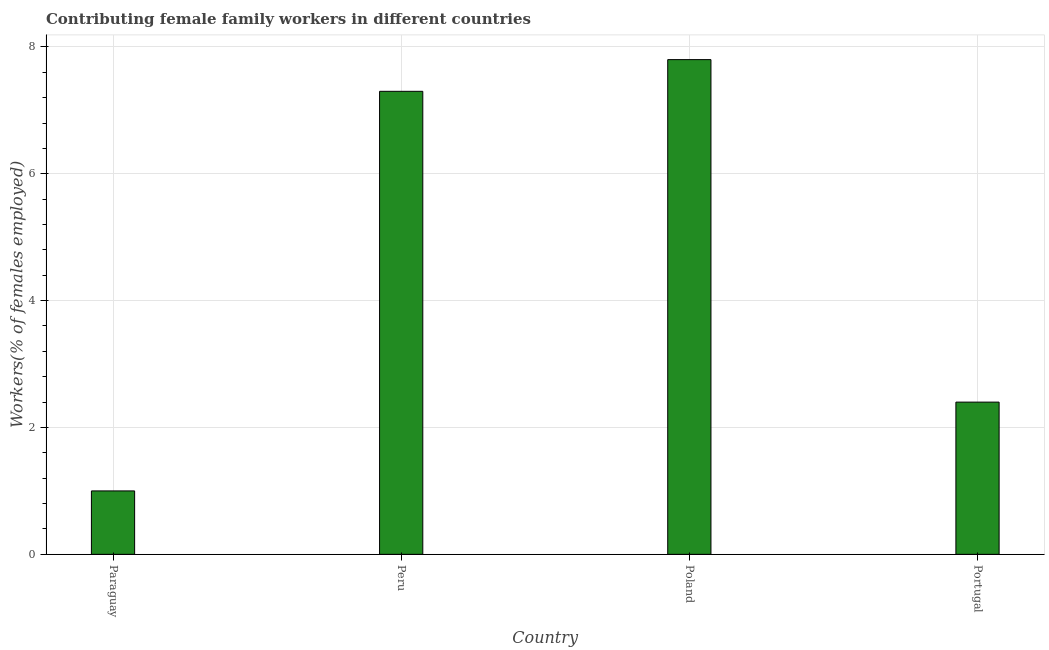Does the graph contain any zero values?
Ensure brevity in your answer.  No. Does the graph contain grids?
Give a very brief answer. Yes. What is the title of the graph?
Offer a very short reply. Contributing female family workers in different countries. What is the label or title of the X-axis?
Your answer should be very brief. Country. What is the label or title of the Y-axis?
Give a very brief answer. Workers(% of females employed). What is the contributing female family workers in Peru?
Your answer should be very brief. 7.3. Across all countries, what is the maximum contributing female family workers?
Make the answer very short. 7.8. In which country was the contributing female family workers minimum?
Give a very brief answer. Paraguay. What is the sum of the contributing female family workers?
Ensure brevity in your answer.  18.5. What is the average contributing female family workers per country?
Offer a very short reply. 4.62. What is the median contributing female family workers?
Ensure brevity in your answer.  4.85. In how many countries, is the contributing female family workers greater than 4 %?
Make the answer very short. 2. What is the ratio of the contributing female family workers in Paraguay to that in Poland?
Provide a succinct answer. 0.13. Is the contributing female family workers in Poland less than that in Portugal?
Make the answer very short. No. Is the difference between the contributing female family workers in Peru and Portugal greater than the difference between any two countries?
Your answer should be very brief. No. What is the difference between the highest and the second highest contributing female family workers?
Offer a terse response. 0.5. Is the sum of the contributing female family workers in Peru and Poland greater than the maximum contributing female family workers across all countries?
Offer a very short reply. Yes. How many countries are there in the graph?
Provide a short and direct response. 4. What is the difference between two consecutive major ticks on the Y-axis?
Offer a terse response. 2. What is the Workers(% of females employed) of Peru?
Give a very brief answer. 7.3. What is the Workers(% of females employed) of Poland?
Offer a terse response. 7.8. What is the Workers(% of females employed) of Portugal?
Provide a succinct answer. 2.4. What is the difference between the Workers(% of females employed) in Paraguay and Peru?
Provide a short and direct response. -6.3. What is the difference between the Workers(% of females employed) in Paraguay and Poland?
Offer a very short reply. -6.8. What is the difference between the Workers(% of females employed) in Peru and Portugal?
Provide a short and direct response. 4.9. What is the ratio of the Workers(% of females employed) in Paraguay to that in Peru?
Your response must be concise. 0.14. What is the ratio of the Workers(% of females employed) in Paraguay to that in Poland?
Your response must be concise. 0.13. What is the ratio of the Workers(% of females employed) in Paraguay to that in Portugal?
Make the answer very short. 0.42. What is the ratio of the Workers(% of females employed) in Peru to that in Poland?
Your answer should be compact. 0.94. What is the ratio of the Workers(% of females employed) in Peru to that in Portugal?
Keep it short and to the point. 3.04. 